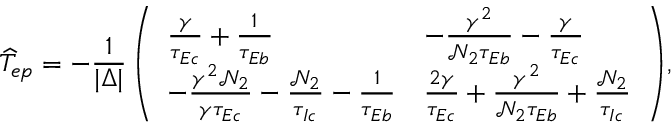Convert formula to latex. <formula><loc_0><loc_0><loc_500><loc_500>\widehat { T } _ { e p } = - \frac { 1 } { | \Delta | } \left ( \begin{array} { l l } { \frac { \gamma } { \tau _ { E c } } + \frac { 1 } { \tau _ { E b } } } & { - \frac { \gamma ^ { 2 } } { \mathcal { N } _ { 2 } \tau _ { E b } } - \frac { \gamma } { \tau _ { E c } } } \\ { - \frac { \gamma ^ { 2 } \mathcal { N } _ { 2 } } { \gamma \tau _ { E c } } - \frac { \mathcal { N } _ { 2 } } { \tau _ { I c } } - \frac { 1 } { \tau _ { E b } } } & { \frac { 2 \gamma } { \tau _ { E c } } + \frac { \gamma ^ { 2 } } { \mathcal { N } _ { 2 } \tau _ { E b } } + \frac { \mathcal { N } _ { 2 } } { \tau _ { I c } } } \end{array} \right ) \, ,</formula> 